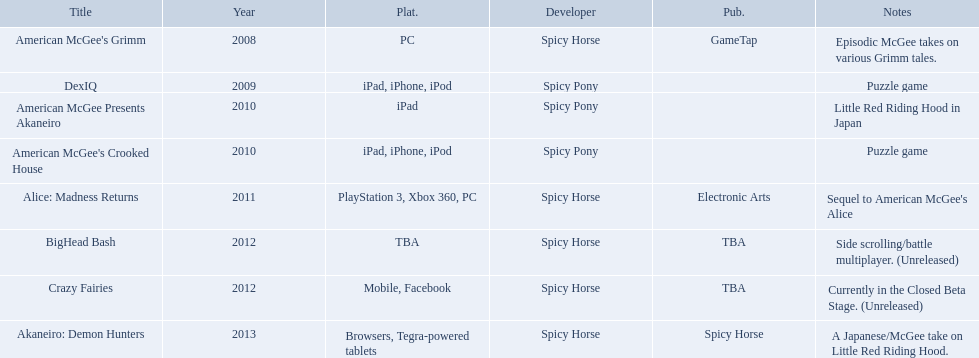Which spicy horse titles are shown? American McGee's Grimm, DexIQ, American McGee Presents Akaneiro, American McGee's Crooked House, Alice: Madness Returns, BigHead Bash, Crazy Fairies, Akaneiro: Demon Hunters. Of those, which are for the ipad? DexIQ, American McGee Presents Akaneiro, American McGee's Crooked House. Which of those are not for the iphone or ipod? American McGee Presents Akaneiro. What are all of the game titles? American McGee's Grimm, DexIQ, American McGee Presents Akaneiro, American McGee's Crooked House, Alice: Madness Returns, BigHead Bash, Crazy Fairies, Akaneiro: Demon Hunters. Which developer developed a game in 2011? Spicy Horse. Who published this game in 2011 Electronic Arts. What was the name of this published game in 2011? Alice: Madness Returns. What are all the titles of games published? American McGee's Grimm, DexIQ, American McGee Presents Akaneiro, American McGee's Crooked House, Alice: Madness Returns, BigHead Bash, Crazy Fairies, Akaneiro: Demon Hunters. What are all the names of the publishers? GameTap, , , , Electronic Arts, TBA, TBA, Spicy Horse. What is the published game title that corresponds to electronic arts? Alice: Madness Returns. 